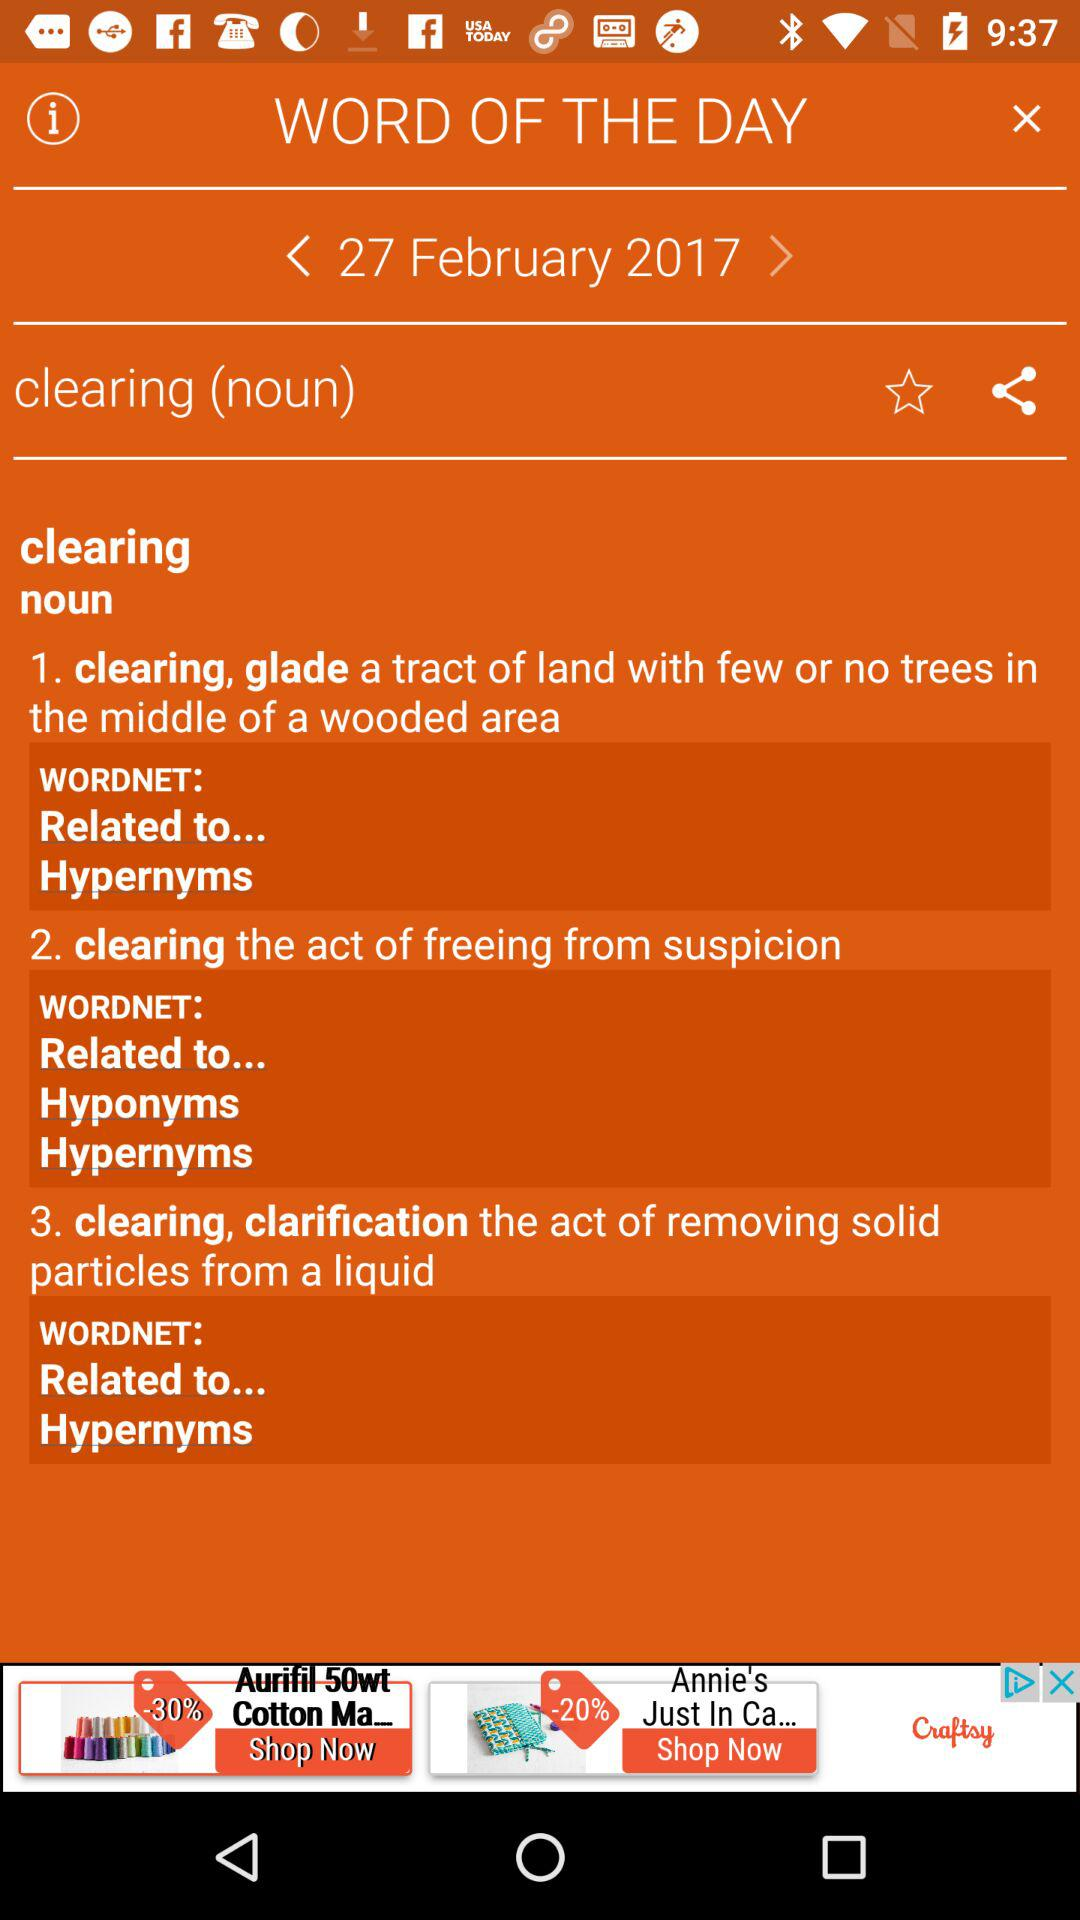What is the meaning of "clearing"? The meaning of "clearing" is "a tract of land with few or no trees in the middle of a wooded area", "the act of freeing from suspicion" and "the act of removing solid particles from a liquid". 